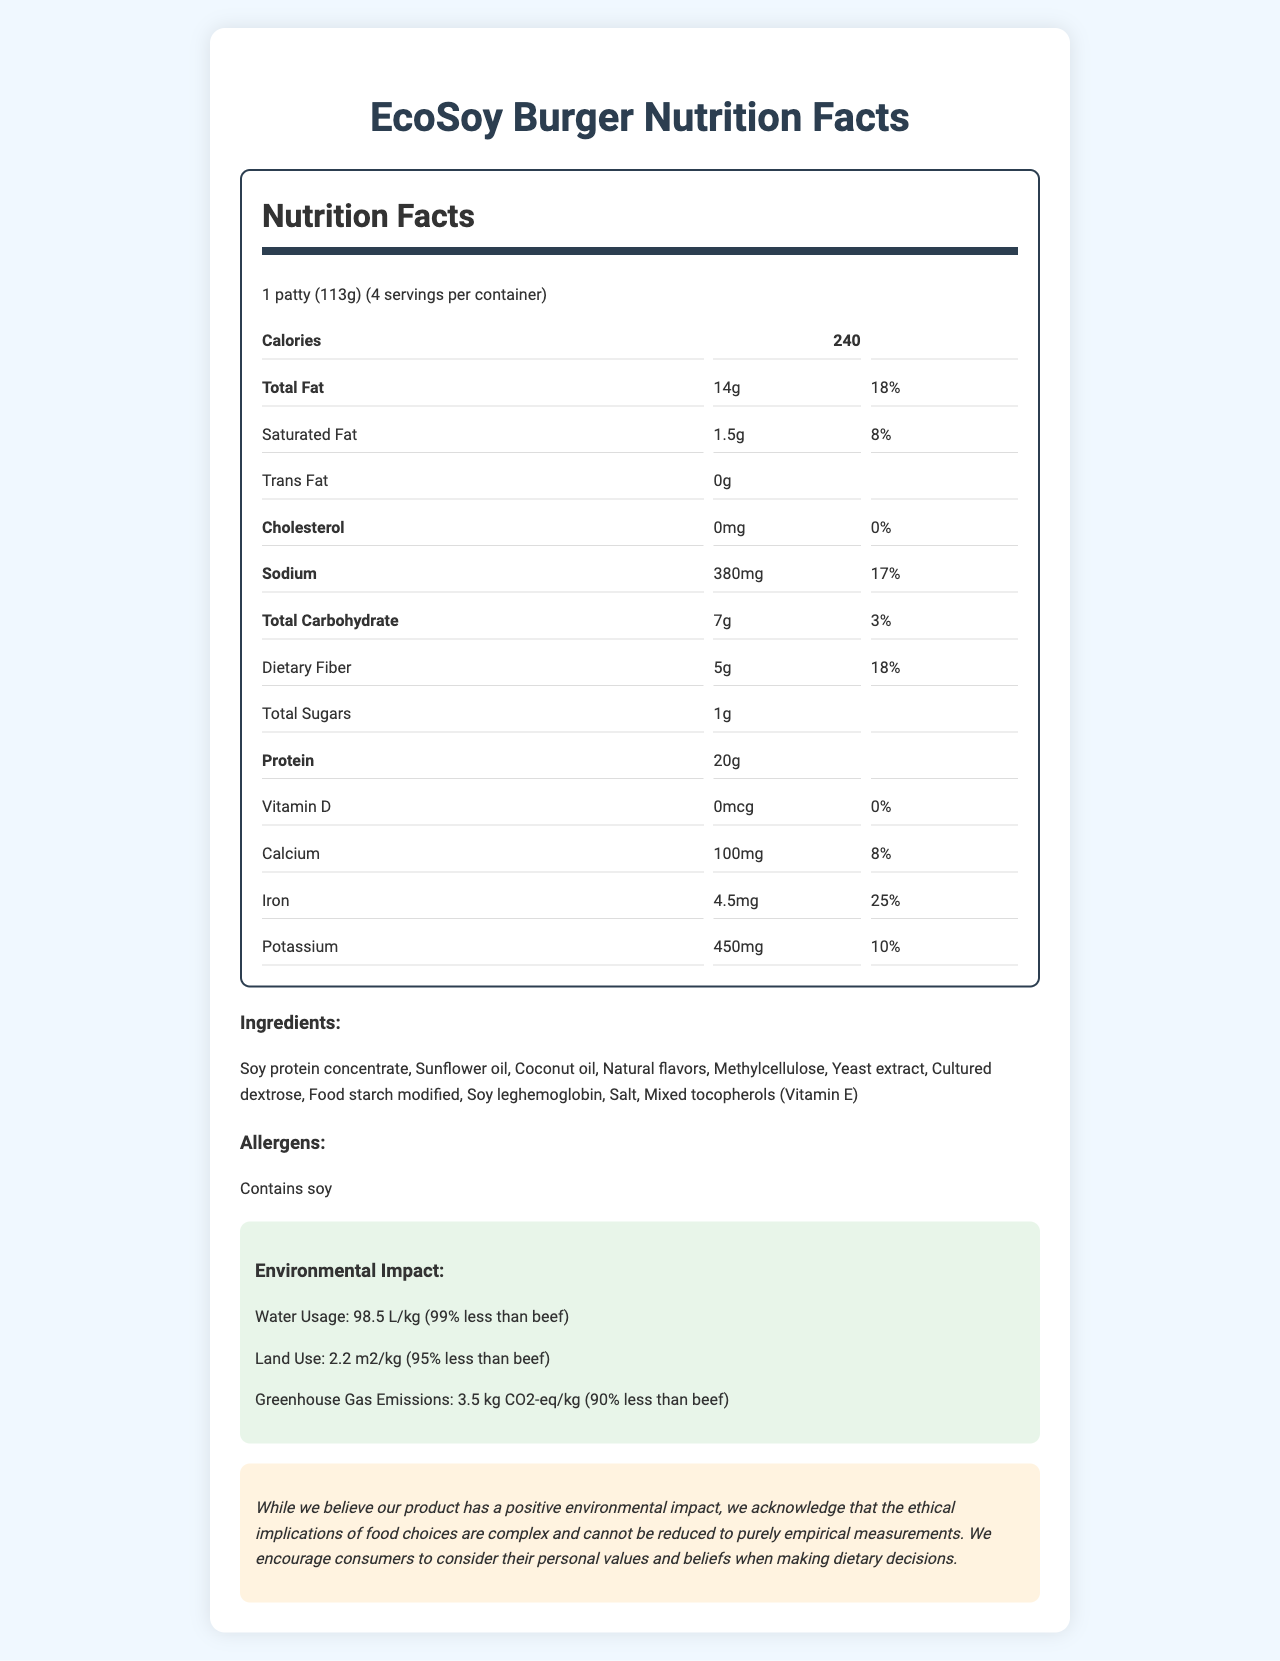what is the serving size of the EcoSoy Burger? The serving size is explicitly stated at the beginning of the Nutrition Facts section.
Answer: 1 patty (113g) how many calories are in one serving of the EcoSoy Burger? The calorie count per serving is directly provided in the Nutrition Facts section.
Answer: 240 how much sodium is in one serving, and what percentage of the daily value does that represent? The Nutrition Facts section lists sodium content as 380 mg and the daily value as 17%.
Answer: 380 mg, 17% does the EcoSoy Burger contain any trans fat? The Nutrition Facts section lists trans fat as 0g, indicating that there is no trans fat.
Answer: No what percentage of daily iron intake does one serving of the EcoSoy Burger provide? The Nutrition Facts section shows that one serving provides 25% of the daily value for iron.
Answer: 25% The EcoSoy Burger has 1g of sugars. What other nutritional content has the same unit measurement and amount? A. Dietary Fiber B. Protein C. Saturated Fat D. Calcium Saturated fat is listed as 1.5g, making it the closest option, but 1g of sugars exactly equals itself.
Answer: C How is the ethical statement at the end of the document framed? A. As a definitive claim about the product's impact B. As an acknowledgment of complexity in ethical implications C. As a discouragement of purchasing decisions based on the product D. As a technical description of the product The ethical statement acknowledges the complexity of ethical implications.
Answer: B is there an issue with allergens in the EcoSoy Burger? The allergens section clearly states that the product contains soy.
Answer: Yes can the exact environmental impact of a beef patty be determined from the document? The document compares the EcoSoy Burger's impact to beef but does not provide exact figures for beef.
Answer: Not enough information summarize the entire document. The document consists of a detailed breakdown of nutrition facts, highlighting the environmental benefits of the EcoSoy Burger compared to beef, along with an ethical consideration section.
Answer: The document provides comprehensive nutritional information and environmental impact statistics for the EcoSoy Burger. It details serving size, calorie content, and percentages of daily values for various nutrients. The ingredients list and allergen information highlight the presence of soy. The environmental impact section emphasizes the product's advantages in water usage, land use, and greenhouse gas emissions compared to beef. An ethical statement encourages consumers to consider personal values when making dietary decisions. what is the protein content per serving of the EcoSoy Burger? The Nutrition Facts section lists the protein content as 20g.
Answer: 20g what is the daily value percentage of dietary fiber provided by one serving? The nutrition label indicates that one serving provides 18% of the daily value for dietary fiber.
Answer: 18% 